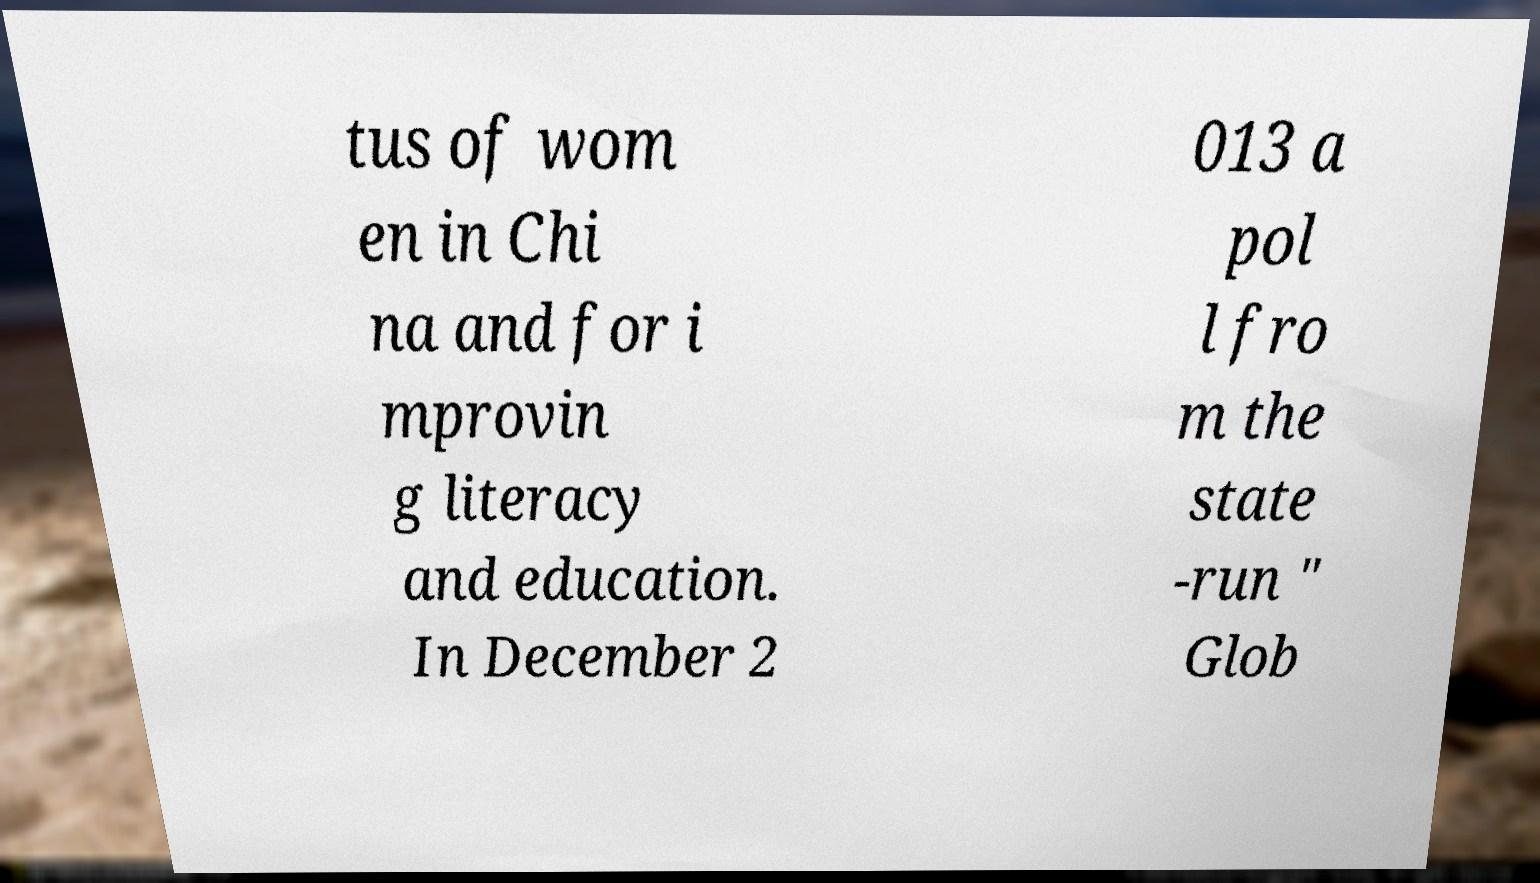Can you read and provide the text displayed in the image?This photo seems to have some interesting text. Can you extract and type it out for me? tus of wom en in Chi na and for i mprovin g literacy and education. In December 2 013 a pol l fro m the state -run " Glob 